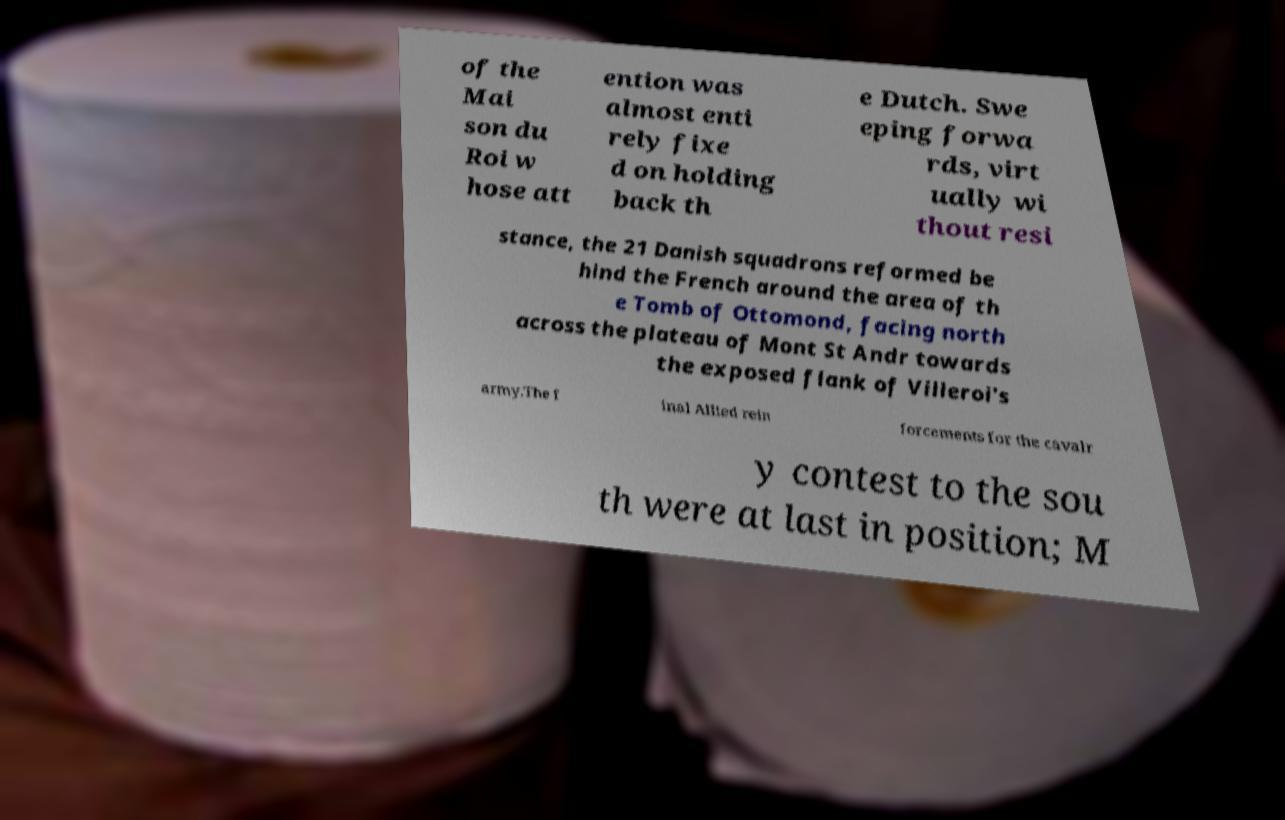Can you read and provide the text displayed in the image?This photo seems to have some interesting text. Can you extract and type it out for me? of the Mai son du Roi w hose att ention was almost enti rely fixe d on holding back th e Dutch. Swe eping forwa rds, virt ually wi thout resi stance, the 21 Danish squadrons reformed be hind the French around the area of th e Tomb of Ottomond, facing north across the plateau of Mont St Andr towards the exposed flank of Villeroi's army.The f inal Allied rein forcements for the cavalr y contest to the sou th were at last in position; M 